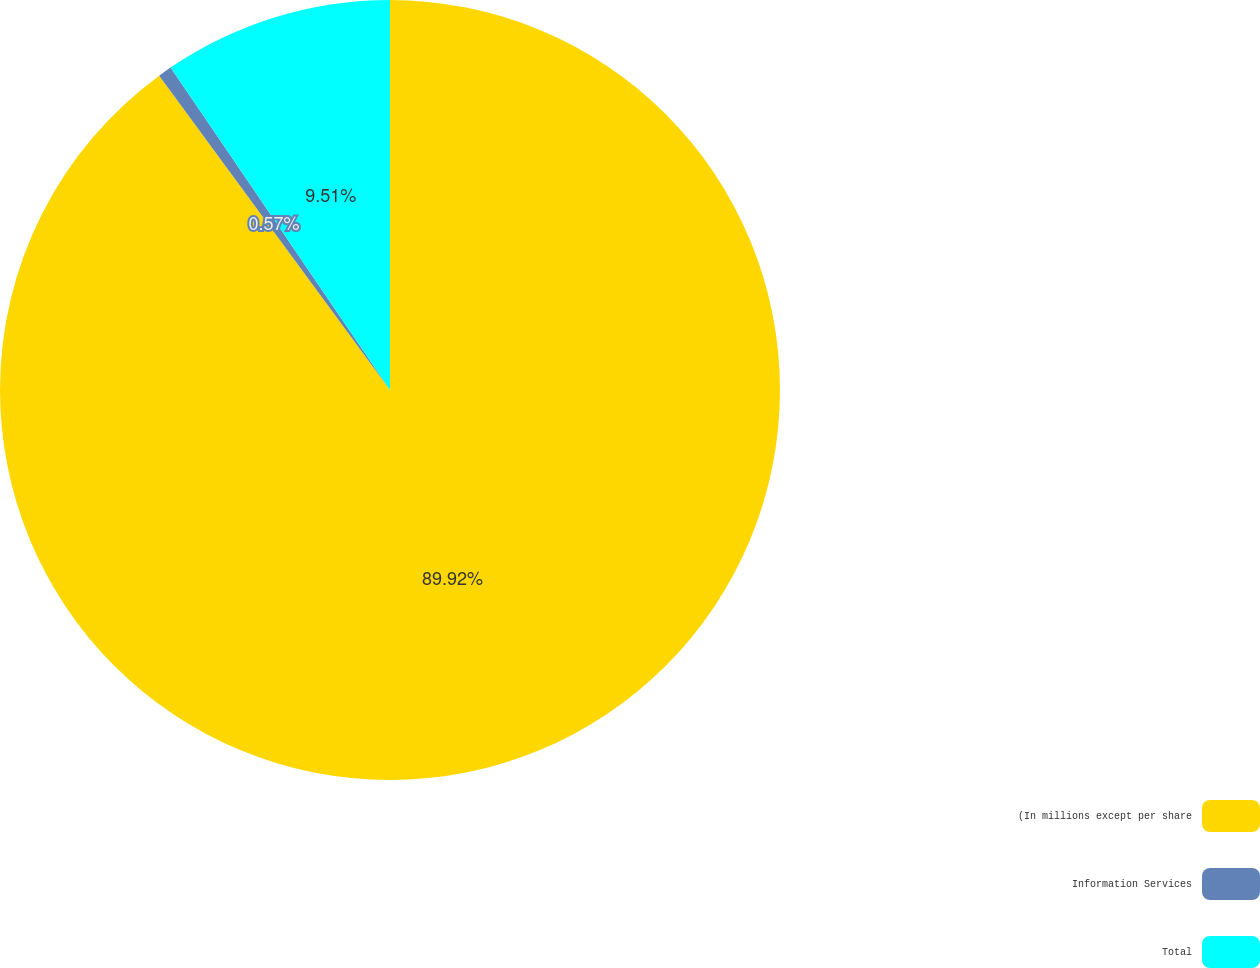Convert chart to OTSL. <chart><loc_0><loc_0><loc_500><loc_500><pie_chart><fcel>(In millions except per share<fcel>Information Services<fcel>Total<nl><fcel>89.92%<fcel>0.57%<fcel>9.51%<nl></chart> 